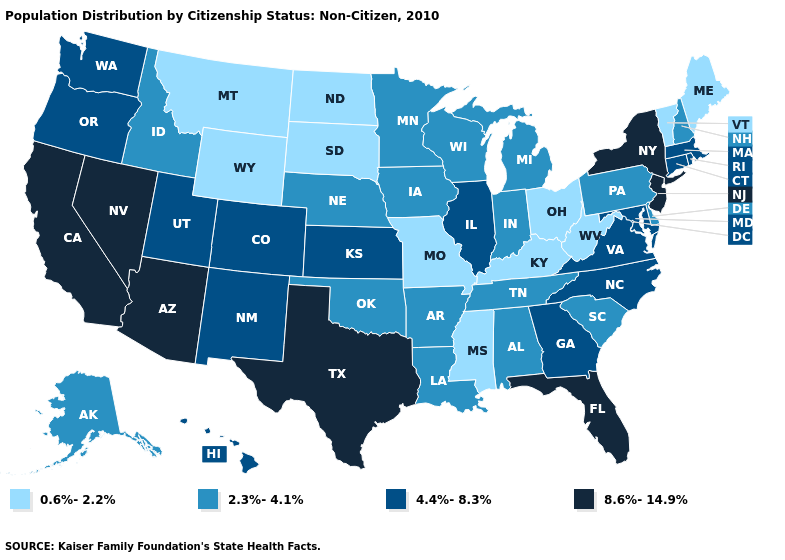What is the lowest value in the USA?
Keep it brief. 0.6%-2.2%. What is the lowest value in the Northeast?
Concise answer only. 0.6%-2.2%. What is the lowest value in the USA?
Give a very brief answer. 0.6%-2.2%. Among the states that border Pennsylvania , which have the highest value?
Answer briefly. New Jersey, New York. Does Arizona have the highest value in the West?
Write a very short answer. Yes. Among the states that border Illinois , does Missouri have the highest value?
Give a very brief answer. No. Does Washington have a higher value than Delaware?
Be succinct. Yes. Name the states that have a value in the range 0.6%-2.2%?
Answer briefly. Kentucky, Maine, Mississippi, Missouri, Montana, North Dakota, Ohio, South Dakota, Vermont, West Virginia, Wyoming. Does Arkansas have the lowest value in the USA?
Be succinct. No. Name the states that have a value in the range 0.6%-2.2%?
Short answer required. Kentucky, Maine, Mississippi, Missouri, Montana, North Dakota, Ohio, South Dakota, Vermont, West Virginia, Wyoming. What is the highest value in the Northeast ?
Be succinct. 8.6%-14.9%. Name the states that have a value in the range 8.6%-14.9%?
Be succinct. Arizona, California, Florida, Nevada, New Jersey, New York, Texas. Does South Dakota have the lowest value in the USA?
Answer briefly. Yes. Name the states that have a value in the range 4.4%-8.3%?
Write a very short answer. Colorado, Connecticut, Georgia, Hawaii, Illinois, Kansas, Maryland, Massachusetts, New Mexico, North Carolina, Oregon, Rhode Island, Utah, Virginia, Washington. Is the legend a continuous bar?
Answer briefly. No. 